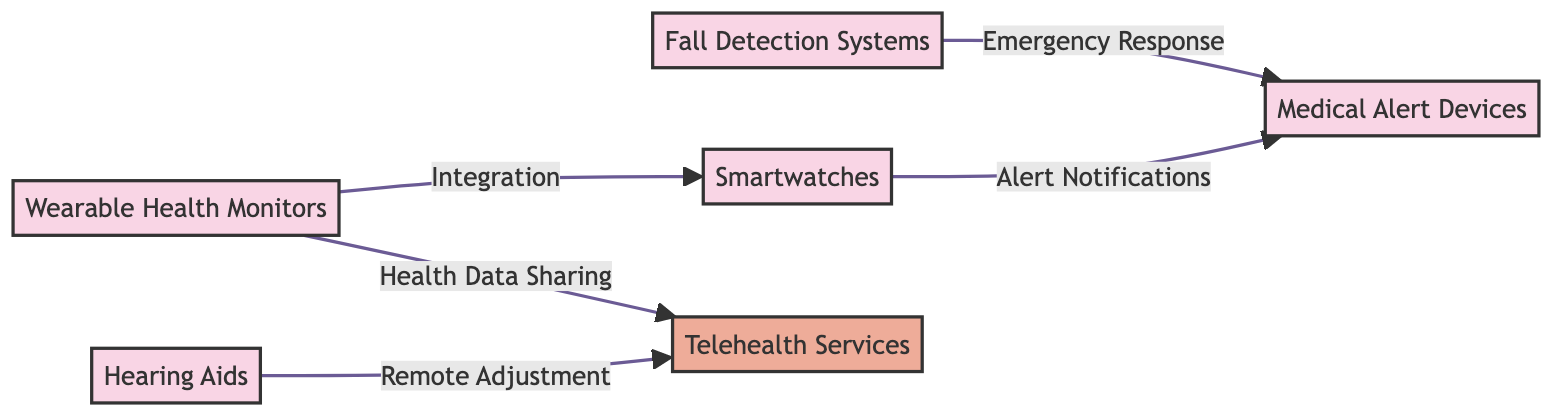What are the five types of biomedical devices shown in the diagram? The diagram lists five types of biomedical devices: Wearable Health Monitors, Fall Detection Systems, Hearing Aids, Smartwatches, and Medical Alert Devices. Each device is represented by a node.
Answer: Wearable Health Monitors, Fall Detection Systems, Hearing Aids, Smartwatches, Medical Alert Devices Which device is directly linked to Smartwatches? The diagram shows that Wearable Health Monitors are connected to Smartwatches with an integration relationship. The arrow indicates a direct link between the two nodes.
Answer: Wearable Health Monitors What type of service is associated with Hearing Aids in the diagram? The diagram indicates that Hearing Aids are connected to Telehealth Services with a relationship labeled "Remote Adjustment," which specifies the type of service utilized.
Answer: Remote Adjustment How many connections are there leading to Medical Alert Devices? The diagram shows two arrows leading into Medical Alert Devices: one from Fall Detection Systems and another from Smartwatches. Counting these connections gives the total number.
Answer: 2 Which device is used for Emergency Response in the context of the diagram? The diagram indicates that Fall Detection Systems are linked to Medical Alert Devices through an "Emergency Response" relationship, implying their role in responding to emergencies.
Answer: Fall Detection Systems What type of data sharing is indicated between Wearable Health Monitors and Telehealth Services? The diagram displays a connection from Wearable Health Monitors to Telehealth Services, labeled "Health Data Sharing," which defines the kind of interaction taking place.
Answer: Health Data Sharing What is the primary function of the Fall Detection Systems as shown in the diagram? Fall Detection Systems are linked to Medical Alert Devices with the relationship labeled "Emergency Response," indicating that their primary function relates to alerting in emergencies.
Answer: Emergency Response Which device provides alert notifications as per the flow of the diagram? The diagram shows that Smartwatches have an arrow pointing to Medical Alert Devices, indicating that the function related to Smartwatches includes providing alert notifications.
Answer: Alert Notifications 